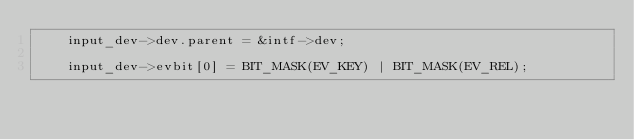Convert code to text. <code><loc_0><loc_0><loc_500><loc_500><_C_>	input_dev->dev.parent = &intf->dev;

	input_dev->evbit[0] = BIT_MASK(EV_KEY) | BIT_MASK(EV_REL);</code> 